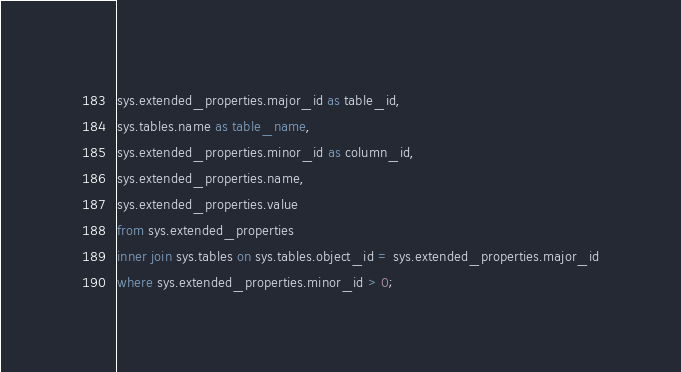Convert code to text. <code><loc_0><loc_0><loc_500><loc_500><_SQL_>sys.extended_properties.major_id as table_id,
sys.tables.name as table_name,
sys.extended_properties.minor_id as column_id,
sys.extended_properties.name,
sys.extended_properties.value
from sys.extended_properties
inner join sys.tables on sys.tables.object_id = sys.extended_properties.major_id
where sys.extended_properties.minor_id > 0;</code> 